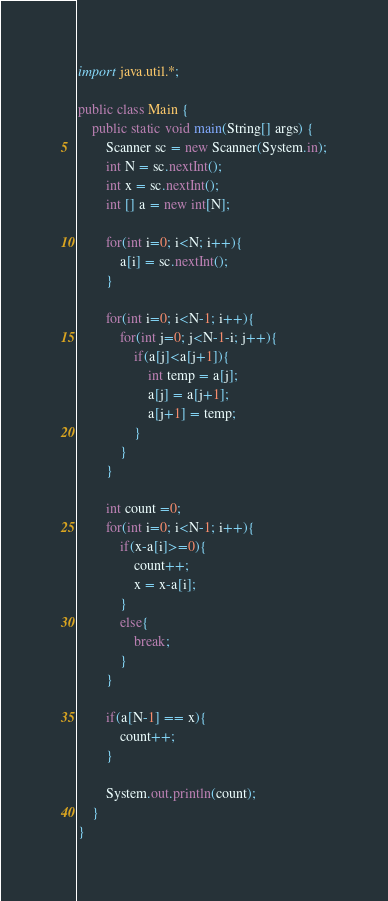<code> <loc_0><loc_0><loc_500><loc_500><_Java_>import java.util.*;

public class Main {
    public static void main(String[] args) {
        Scanner sc = new Scanner(System.in);
        int N = sc.nextInt();
        int x = sc.nextInt();
        int [] a = new int[N];
        
        for(int i=0; i<N; i++){
            a[i] = sc.nextInt();
        }
    
        for(int i=0; i<N-1; i++){
            for(int j=0; j<N-1-i; j++){
                if(a[j]<a[j+1]){
                    int temp = a[j];
                    a[j] = a[j+1];
                    a[j+1] = temp;
                }
            }
        }
            
        int count =0;
        for(int i=0; i<N-1; i++){
            if(x-a[i]>=0){
                count++;
                x = x-a[i];
            }
            else{
                break;
            }
        }
        
        if(a[N-1] == x){
            count++;
        }
        
        System.out.println(count);
    }
}
</code> 